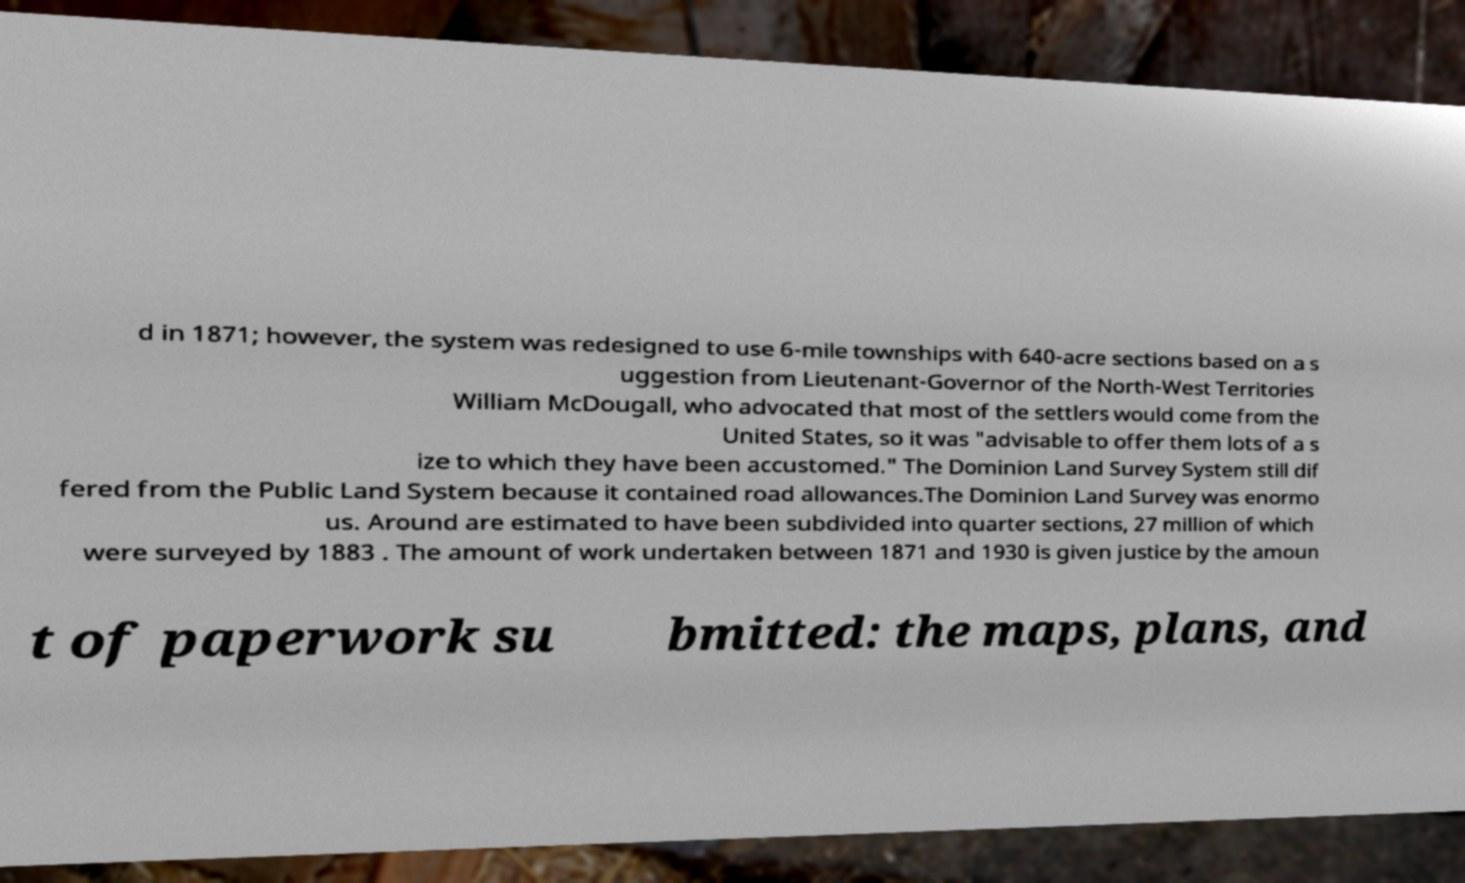Can you accurately transcribe the text from the provided image for me? d in 1871; however, the system was redesigned to use 6-mile townships with 640-acre sections based on a s uggestion from Lieutenant-Governor of the North-West Territories William McDougall, who advocated that most of the settlers would come from the United States, so it was "advisable to offer them lots of a s ize to which they have been accustomed." The Dominion Land Survey System still dif fered from the Public Land System because it contained road allowances.The Dominion Land Survey was enormo us. Around are estimated to have been subdivided into quarter sections, 27 million of which were surveyed by 1883 . The amount of work undertaken between 1871 and 1930 is given justice by the amoun t of paperwork su bmitted: the maps, plans, and 